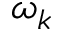Convert formula to latex. <formula><loc_0><loc_0><loc_500><loc_500>\omega _ { k }</formula> 